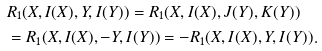<formula> <loc_0><loc_0><loc_500><loc_500>& R _ { 1 } ( X , I ( X ) , Y , I ( Y ) ) = R _ { 1 } ( X , I ( X ) , J ( Y ) , K ( Y ) ) \\ & = R _ { 1 } ( X , I ( X ) , - Y , I ( Y ) ) = - R _ { 1 } ( X , I ( X ) , Y , I ( Y ) ) .</formula> 